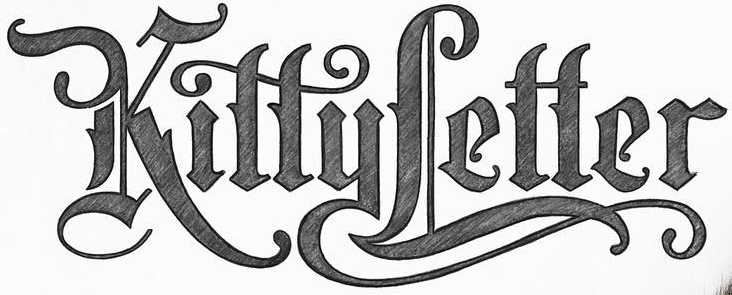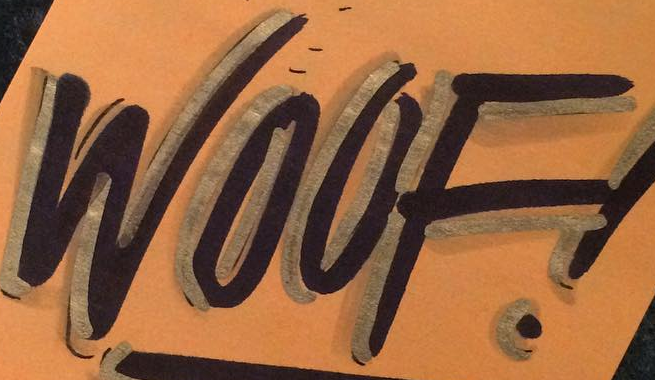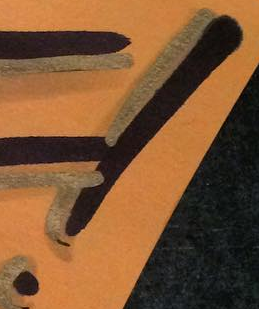What text is displayed in these images sequentially, separated by a semicolon? KittyLetter; WOOF; ! 